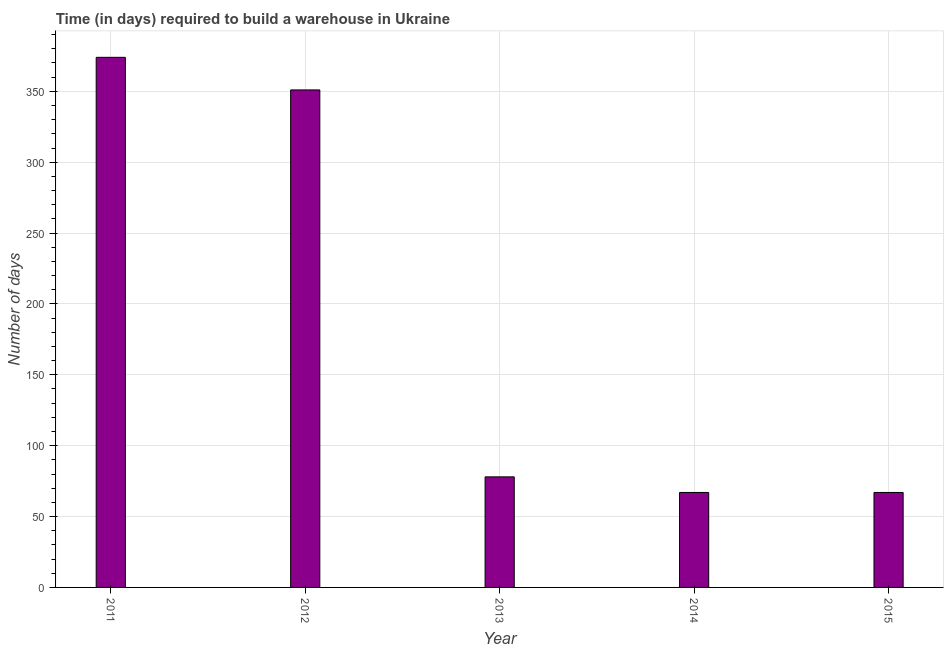Does the graph contain grids?
Give a very brief answer. Yes. What is the title of the graph?
Provide a short and direct response. Time (in days) required to build a warehouse in Ukraine. What is the label or title of the X-axis?
Give a very brief answer. Year. What is the label or title of the Y-axis?
Give a very brief answer. Number of days. Across all years, what is the maximum time required to build a warehouse?
Make the answer very short. 374. What is the sum of the time required to build a warehouse?
Keep it short and to the point. 937. What is the difference between the time required to build a warehouse in 2013 and 2014?
Your answer should be very brief. 11. What is the average time required to build a warehouse per year?
Offer a terse response. 187. In how many years, is the time required to build a warehouse greater than 90 days?
Give a very brief answer. 2. Do a majority of the years between 2015 and 2012 (inclusive) have time required to build a warehouse greater than 50 days?
Provide a short and direct response. Yes. Is the difference between the time required to build a warehouse in 2011 and 2015 greater than the difference between any two years?
Your answer should be very brief. Yes. What is the difference between the highest and the second highest time required to build a warehouse?
Give a very brief answer. 23. What is the difference between the highest and the lowest time required to build a warehouse?
Offer a terse response. 307. In how many years, is the time required to build a warehouse greater than the average time required to build a warehouse taken over all years?
Ensure brevity in your answer.  2. How many bars are there?
Make the answer very short. 5. Are all the bars in the graph horizontal?
Make the answer very short. No. Are the values on the major ticks of Y-axis written in scientific E-notation?
Your answer should be compact. No. What is the Number of days of 2011?
Your response must be concise. 374. What is the Number of days in 2012?
Provide a short and direct response. 351. What is the Number of days of 2013?
Provide a succinct answer. 78. What is the difference between the Number of days in 2011 and 2012?
Your answer should be compact. 23. What is the difference between the Number of days in 2011 and 2013?
Provide a succinct answer. 296. What is the difference between the Number of days in 2011 and 2014?
Keep it short and to the point. 307. What is the difference between the Number of days in 2011 and 2015?
Your response must be concise. 307. What is the difference between the Number of days in 2012 and 2013?
Ensure brevity in your answer.  273. What is the difference between the Number of days in 2012 and 2014?
Ensure brevity in your answer.  284. What is the difference between the Number of days in 2012 and 2015?
Provide a succinct answer. 284. What is the difference between the Number of days in 2013 and 2014?
Offer a very short reply. 11. What is the ratio of the Number of days in 2011 to that in 2012?
Offer a very short reply. 1.07. What is the ratio of the Number of days in 2011 to that in 2013?
Your response must be concise. 4.79. What is the ratio of the Number of days in 2011 to that in 2014?
Your answer should be very brief. 5.58. What is the ratio of the Number of days in 2011 to that in 2015?
Give a very brief answer. 5.58. What is the ratio of the Number of days in 2012 to that in 2014?
Keep it short and to the point. 5.24. What is the ratio of the Number of days in 2012 to that in 2015?
Provide a short and direct response. 5.24. What is the ratio of the Number of days in 2013 to that in 2014?
Keep it short and to the point. 1.16. What is the ratio of the Number of days in 2013 to that in 2015?
Your answer should be very brief. 1.16. 